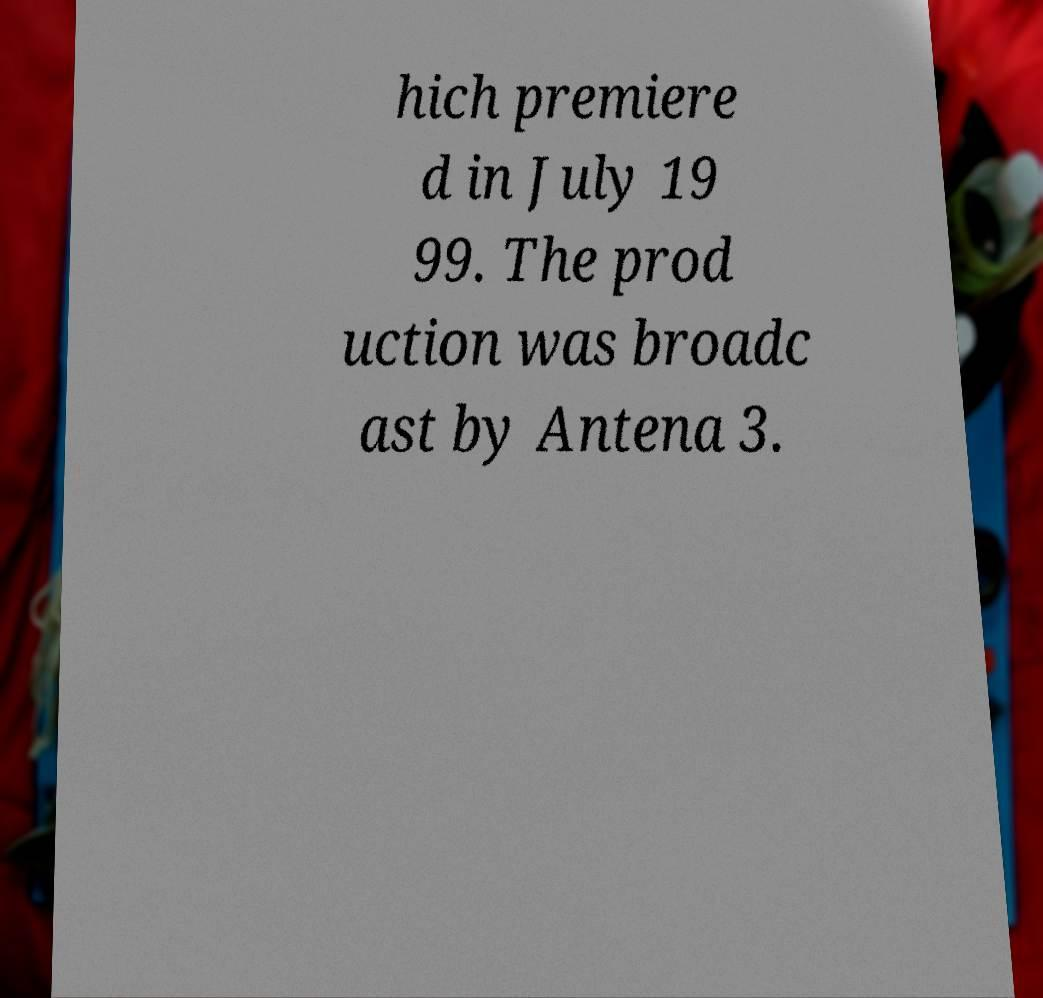Could you extract and type out the text from this image? hich premiere d in July 19 99. The prod uction was broadc ast by Antena 3. 